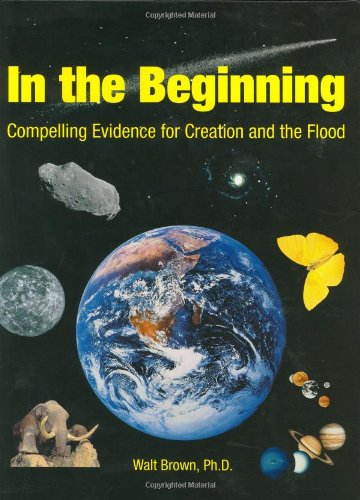What is the title of this book? The complete title of the book shown in the image is 'In the Beginning: Compelling Evidence for Creation and the Flood (7th Edition)', suggesting a detailed exploration of creationist views. 